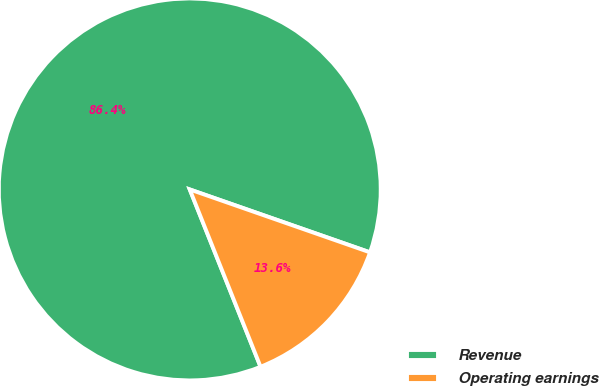Convert chart. <chart><loc_0><loc_0><loc_500><loc_500><pie_chart><fcel>Revenue<fcel>Operating earnings<nl><fcel>86.39%<fcel>13.61%<nl></chart> 